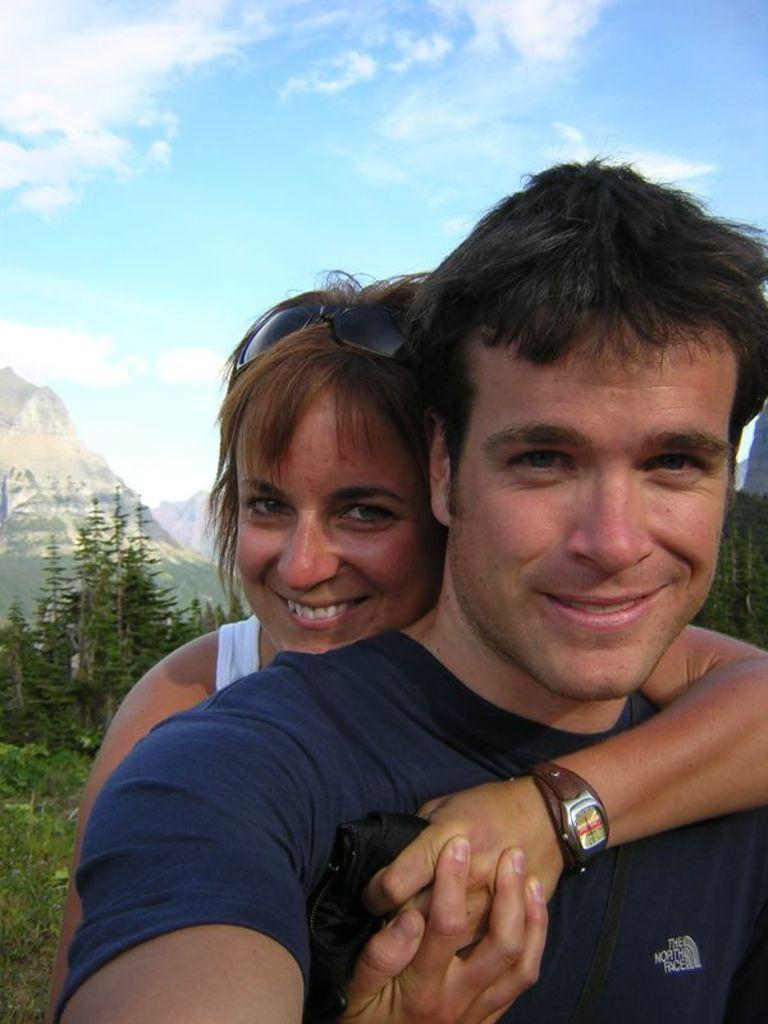Who are the subjects in the image? There is a boy and a girl in the image. Where are the boy and girl located in the image? The boy and girl are in the center of the image. What can be seen in the background of the image? There is greenery in the background of the image. What type of pen is the boy holding in the image? There is no pen present in the image; the boy and girl are the main subjects. 